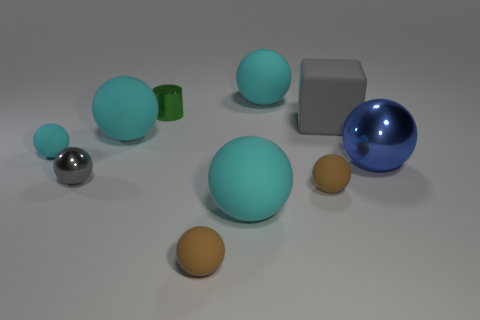How many cyan balls must be subtracted to get 1 cyan balls? 3 Subtract all blue metallic spheres. How many spheres are left? 7 Subtract all cyan spheres. How many spheres are left? 4 Subtract all brown cubes. How many brown spheres are left? 2 Subtract 1 cubes. How many cubes are left? 0 Subtract all blocks. How many objects are left? 9 Subtract all yellow blocks. Subtract all red balls. How many blocks are left? 1 Subtract all large brown metal objects. Subtract all green things. How many objects are left? 9 Add 9 small green things. How many small green things are left? 10 Add 5 brown matte balls. How many brown matte balls exist? 7 